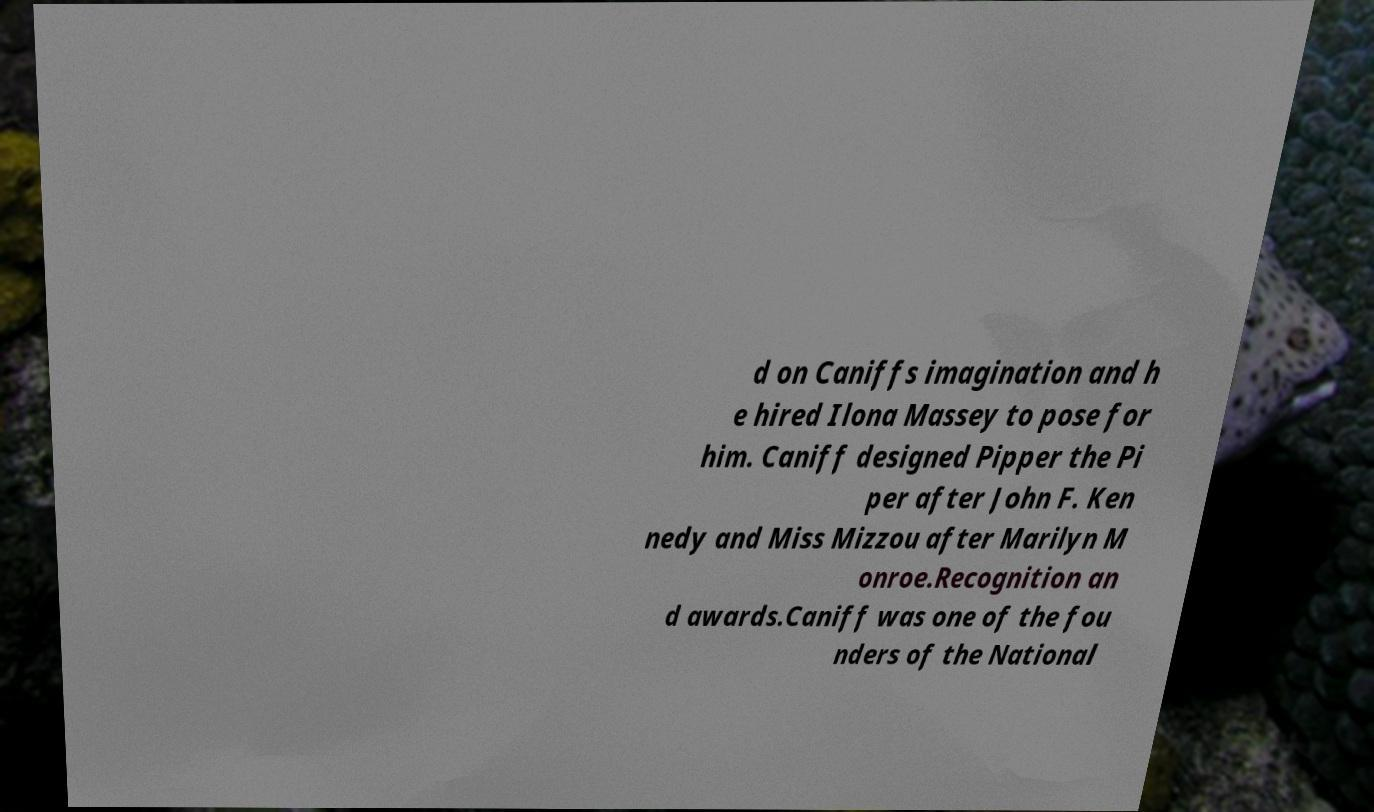Can you accurately transcribe the text from the provided image for me? d on Caniffs imagination and h e hired Ilona Massey to pose for him. Caniff designed Pipper the Pi per after John F. Ken nedy and Miss Mizzou after Marilyn M onroe.Recognition an d awards.Caniff was one of the fou nders of the National 